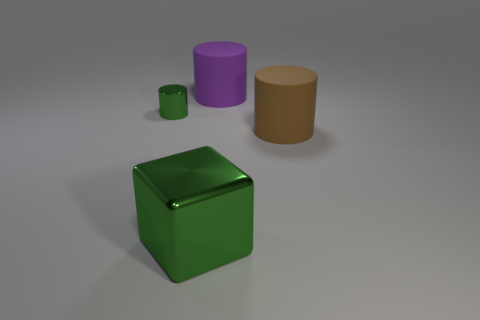What material is the green thing to the left of the large metallic object?
Provide a succinct answer. Metal. How many other objects are there of the same shape as the big green thing?
Your answer should be compact. 0. Does the purple object have the same shape as the large green thing?
Your answer should be very brief. No. There is a purple cylinder; are there any purple objects behind it?
Your answer should be very brief. No. How many things are tiny green cylinders or green cubes?
Provide a short and direct response. 2. How many other objects are there of the same size as the green cylinder?
Give a very brief answer. 0. What number of large matte cylinders are in front of the tiny green metal cylinder and left of the brown rubber cylinder?
Your answer should be very brief. 0. There is a matte thing behind the tiny green cylinder; is it the same size as the shiny thing to the right of the small metal cylinder?
Offer a terse response. Yes. There is a thing that is right of the large purple rubber object; what is its size?
Your answer should be compact. Large. What number of things are metal objects that are to the left of the big green metal block or big rubber things that are in front of the green cylinder?
Keep it short and to the point. 2. 